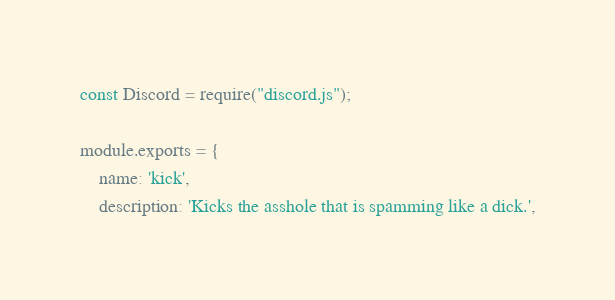<code> <loc_0><loc_0><loc_500><loc_500><_JavaScript_>const Discord = require("discord.js");

module.exports = {
    name: 'kick',
    description: 'Kicks the asshole that is spamming like a dick.',</code> 